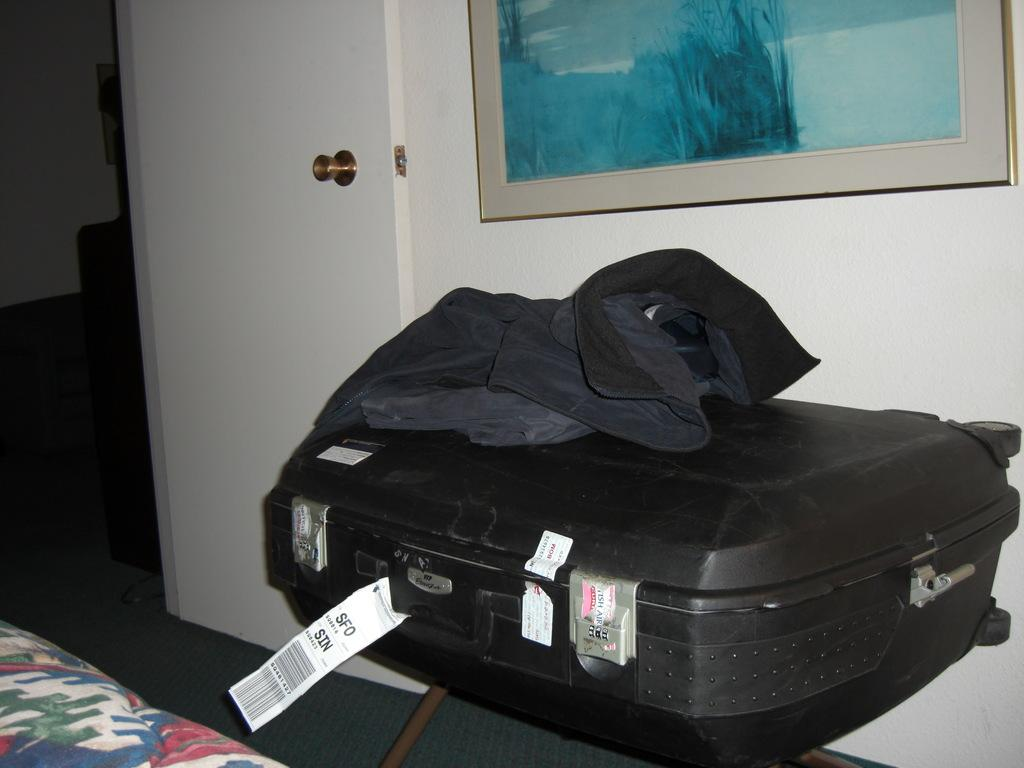What type of luggage is visible in the image? There is a black suitcase in the image. What is placed on top of the suitcase? There is a jacket on top of the suitcase. Can you describe any decorative elements in the image? There is a photo frame on the wall in the image. What type of loaf is sitting on the suitcase in the image? There is no loaf present in the image; it features a black suitcase with a jacket on top and a photo frame on the wall. 